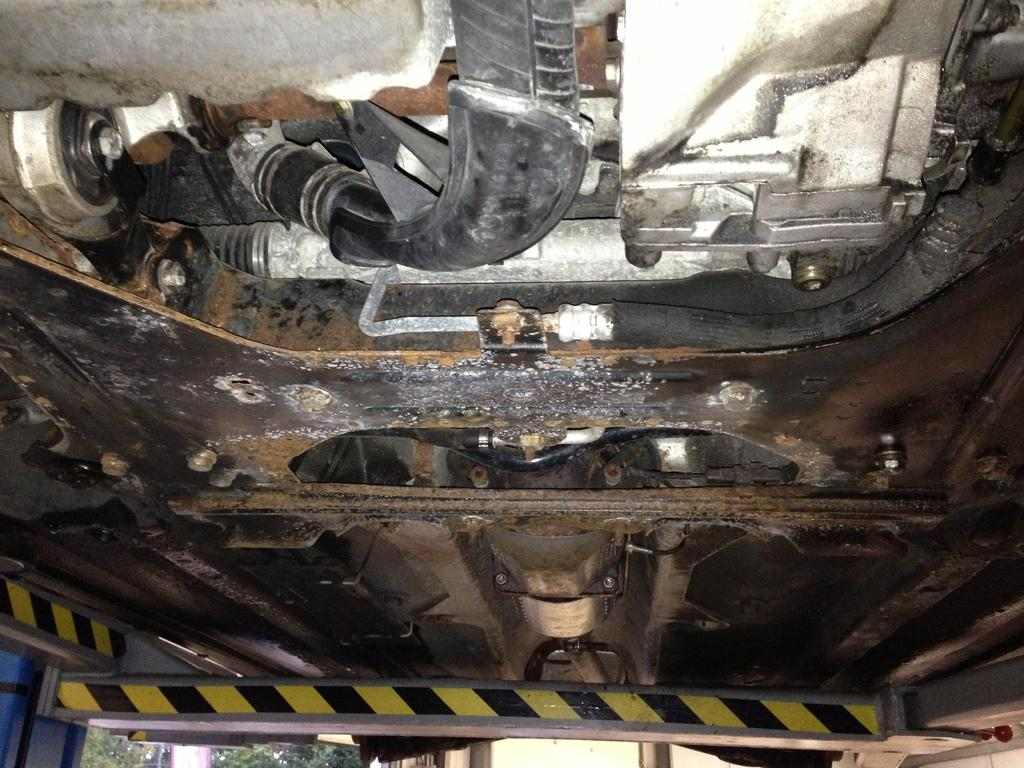What is the main subject of the image? The main subject of the image is a vehicle. From where is the view of the vehicle taken? The view is from below the engine. What type of payment method is accepted for the cushion selection in the image? There is no payment method or cushion selection present in the image; it is a view of a vehicle from below the engine. 